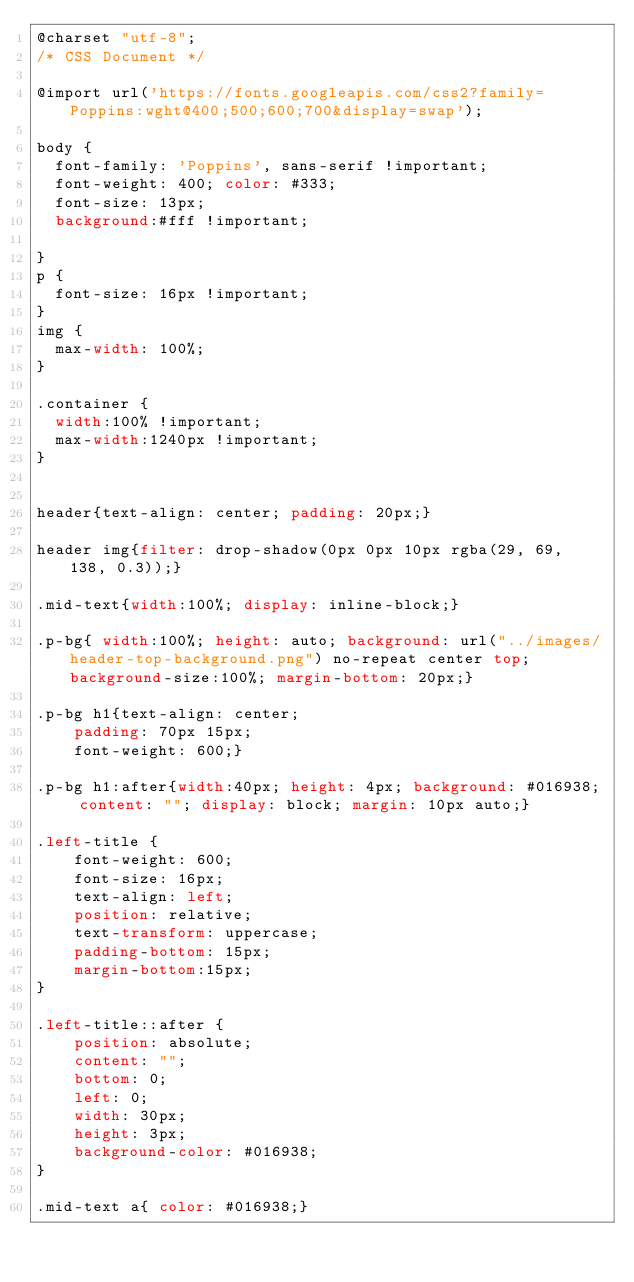Convert code to text. <code><loc_0><loc_0><loc_500><loc_500><_CSS_>@charset "utf-8";
/* CSS Document */

@import url('https://fonts.googleapis.com/css2?family=Poppins:wght@400;500;600;700&display=swap');

body {
	font-family: 'Poppins', sans-serif !important;
	font-weight: 400; color: #333;
	font-size: 13px;
	background:#fff !important;

}
p {
	font-size: 16px !important;
}
img {
	max-width: 100%;
}

.container {
	width:100% !important;
	max-width:1240px !important;
}


header{text-align: center; padding: 20px;}

header img{filter: drop-shadow(0px 0px 10px rgba(29, 69, 138, 0.3));}

.mid-text{width:100%; display: inline-block;}

.p-bg{ width:100%; height: auto; background: url("../images/header-top-background.png") no-repeat center top; background-size:100%; margin-bottom: 20px;}

.p-bg h1{text-align: center;
    padding: 70px 15px;
    font-weight: 600;}

.p-bg h1:after{width:40px; height: 4px; background: #016938; content: ""; display: block; margin: 10px auto;}

.left-title {
    font-weight: 600;
    font-size: 16px;
    text-align: left;
    position: relative;
    text-transform: uppercase;
    padding-bottom: 15px;
    margin-bottom:15px;
}

.left-title::after {
    position: absolute;
    content: "";
    bottom: 0;
    left: 0;
    width: 30px;
    height: 3px;
    background-color: #016938;
}

.mid-text a{ color: #016938;}
</code> 